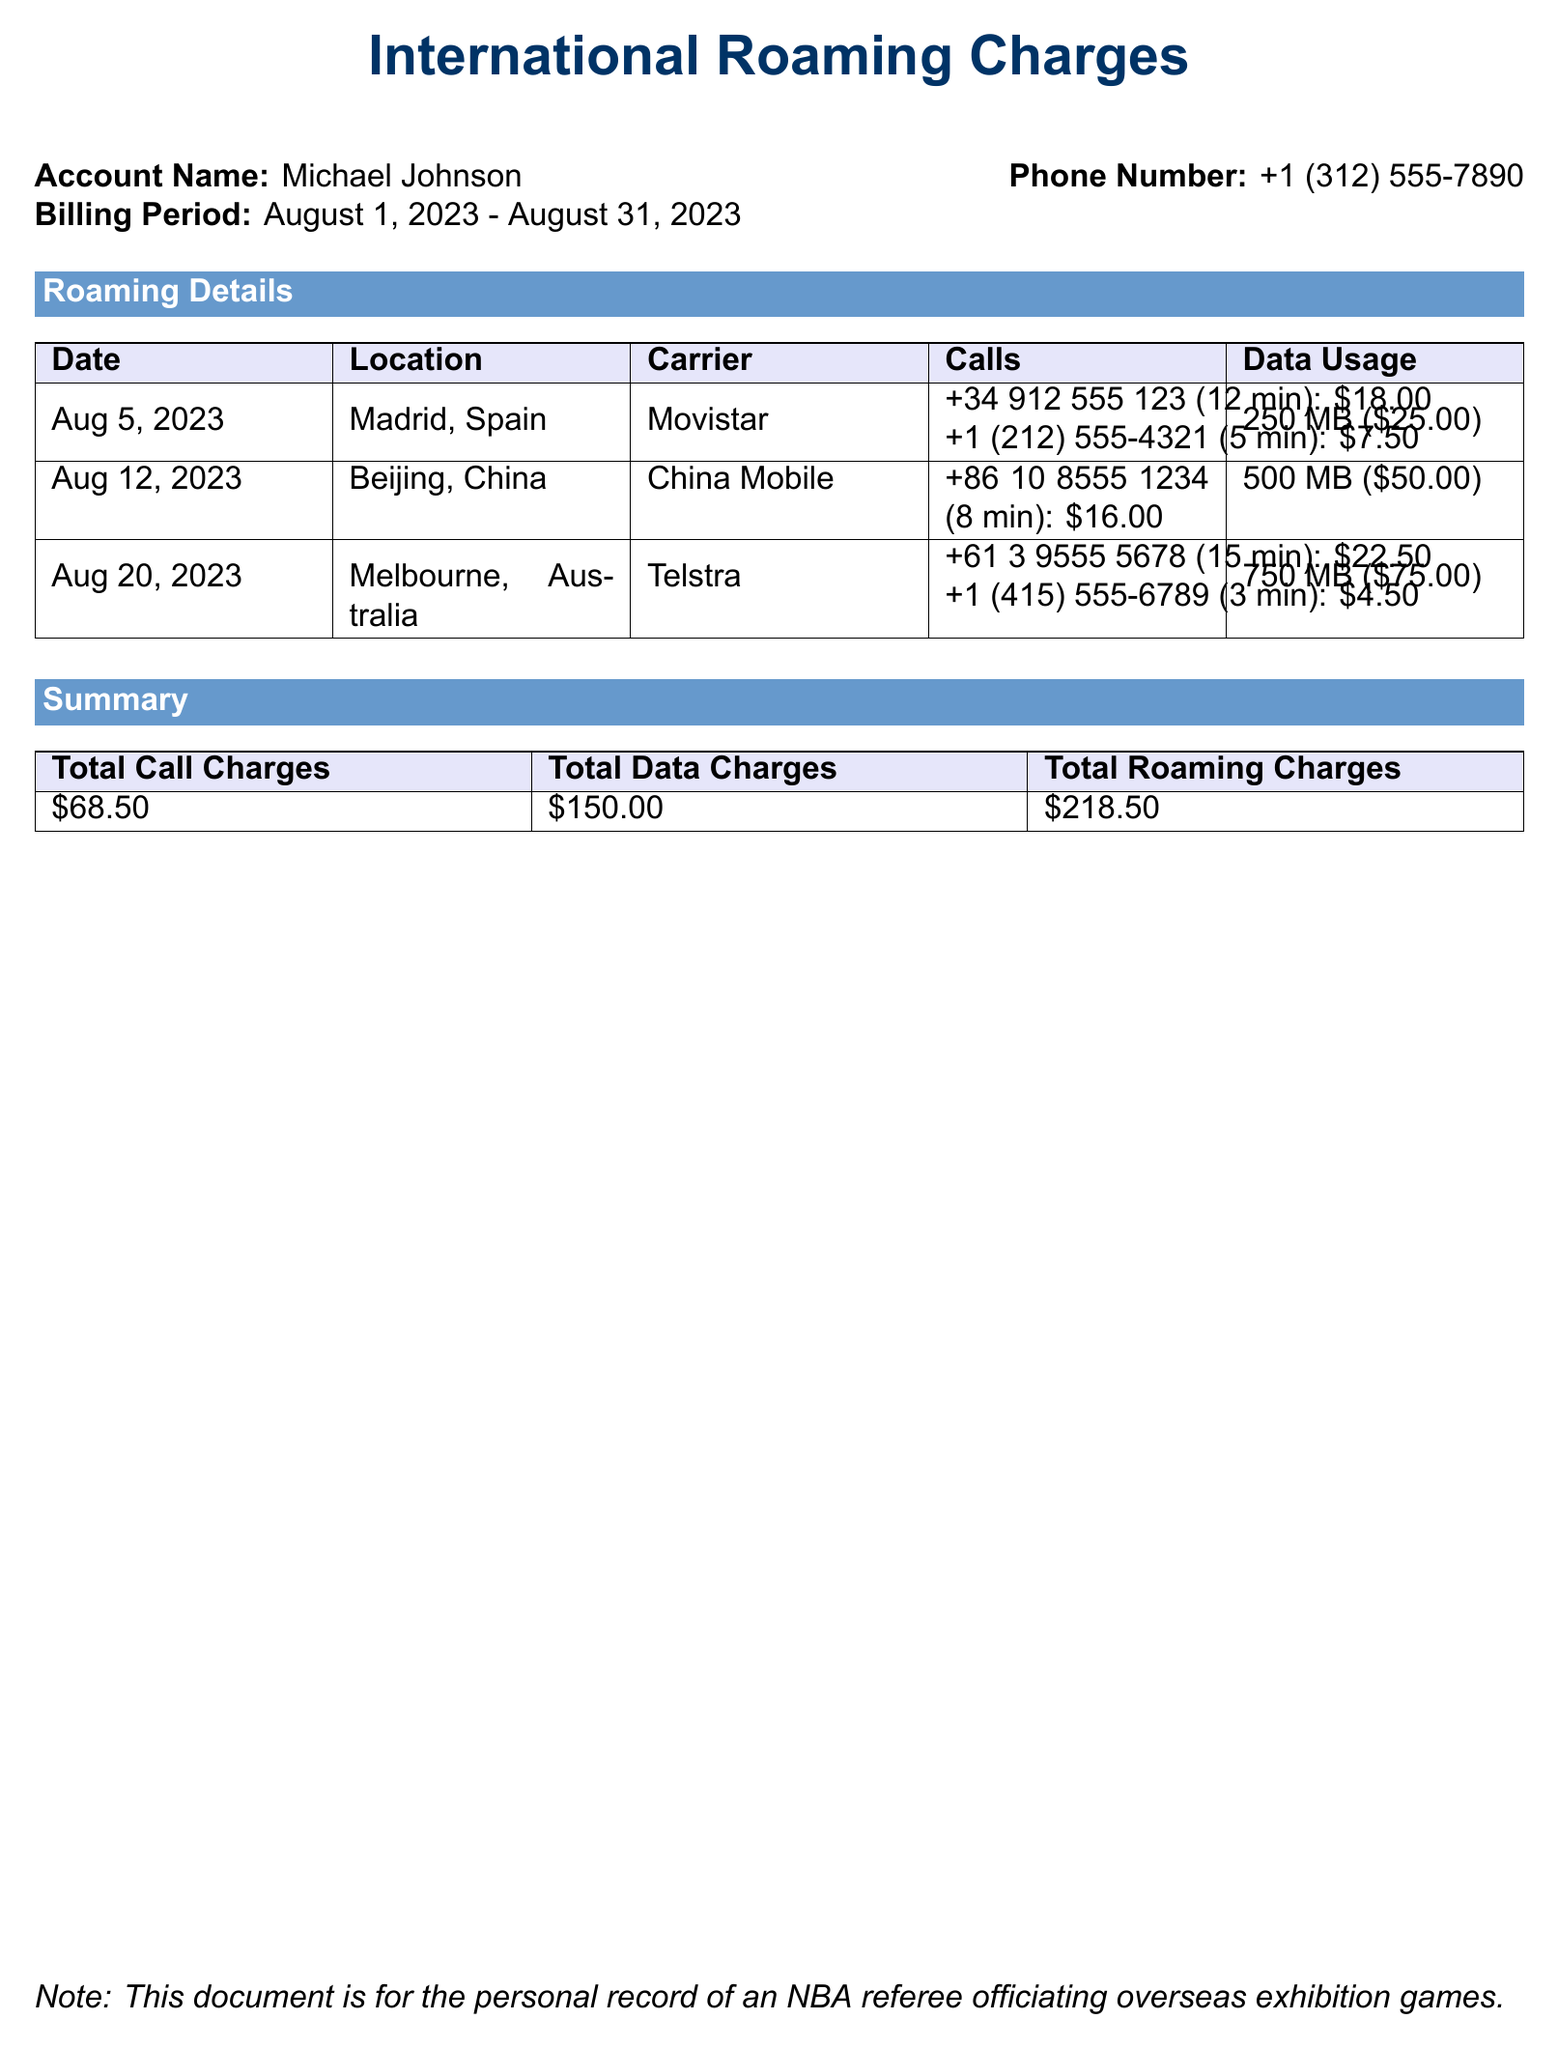What is the account name? The account name is provided as part of the document's header and is specified as "Michael Johnson."
Answer: Michael Johnson What is the billing period? The billing period is listed directly under the account name, ranging from "August 1, 2023 - August 31, 2023."
Answer: August 1, 2023 - August 31, 2023 What was the total call charges? The total call charges are summarized in the final table, specifically stated as "$68.50."
Answer: $68.50 How many minutes were spent on calls in Melbourne? In the roaming details for Melbourne, it lists calls with total time of "15 min" and "3 min," indicating a sum of 18 minutes.
Answer: 18 min What is the total roaming charges? The total roaming charges can be found in the summary table, and it is provided as "$218.50."
Answer: $218.50 How much did the data usage in Madrid cost? The cost for data usage in Madrid is specifically shown in the roaming details as "$25.00."
Answer: $25.00 What carrier was used in Beijing? The carrier listed for the calls made in Beijing is "China Mobile."
Answer: China Mobile What is the total data charges? The total data charges are given in the summary table and clearly stated as "$150.00."
Answer: $150.00 How many MB of data were used in total? By adding all the data usage from each location, the total data usage is 250 MB + 500 MB + 750 MB, which equals 1500 MB.
Answer: 1500 MB 